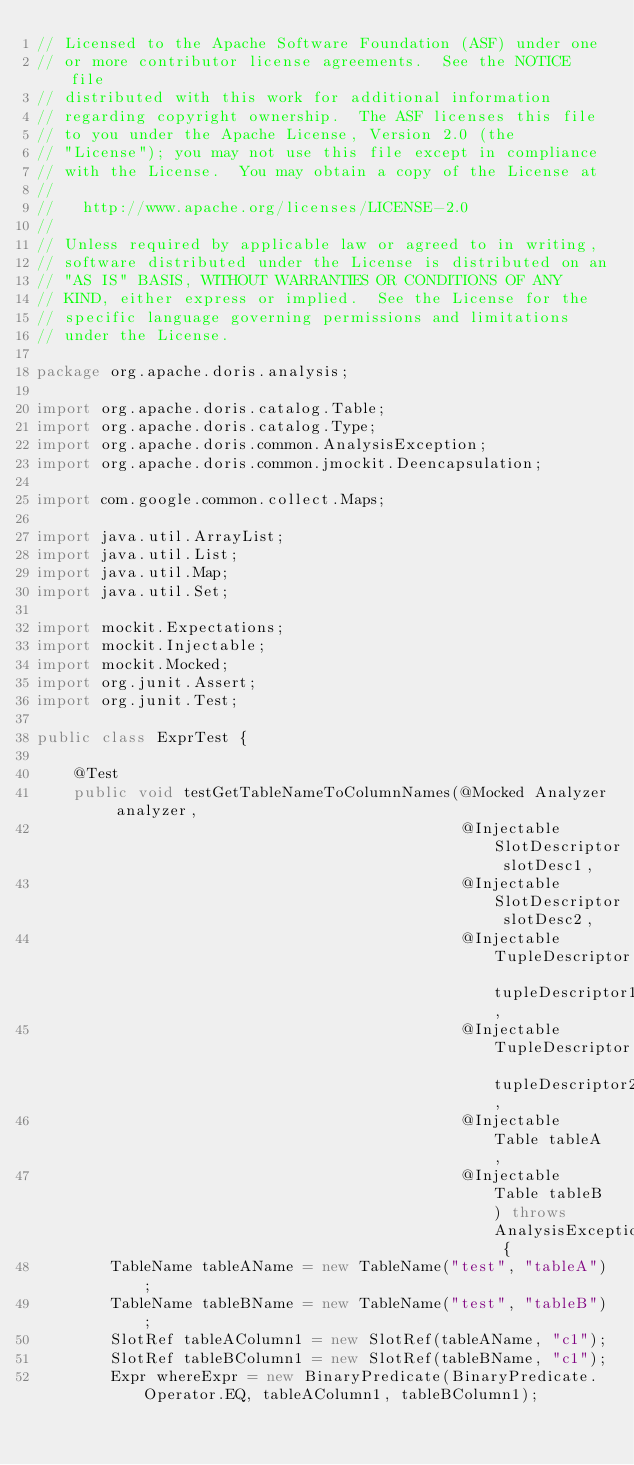Convert code to text. <code><loc_0><loc_0><loc_500><loc_500><_Java_>// Licensed to the Apache Software Foundation (ASF) under one
// or more contributor license agreements.  See the NOTICE file
// distributed with this work for additional information
// regarding copyright ownership.  The ASF licenses this file
// to you under the Apache License, Version 2.0 (the
// "License"); you may not use this file except in compliance
// with the License.  You may obtain a copy of the License at
//
//   http://www.apache.org/licenses/LICENSE-2.0
//
// Unless required by applicable law or agreed to in writing,
// software distributed under the License is distributed on an
// "AS IS" BASIS, WITHOUT WARRANTIES OR CONDITIONS OF ANY
// KIND, either express or implied.  See the License for the
// specific language governing permissions and limitations
// under the License.

package org.apache.doris.analysis;

import org.apache.doris.catalog.Table;
import org.apache.doris.catalog.Type;
import org.apache.doris.common.AnalysisException;
import org.apache.doris.common.jmockit.Deencapsulation;

import com.google.common.collect.Maps;

import java.util.ArrayList;
import java.util.List;
import java.util.Map;
import java.util.Set;

import mockit.Expectations;
import mockit.Injectable;
import mockit.Mocked;
import org.junit.Assert;
import org.junit.Test;

public class ExprTest {

    @Test
    public void testGetTableNameToColumnNames(@Mocked Analyzer analyzer,
                                              @Injectable SlotDescriptor slotDesc1,
                                              @Injectable SlotDescriptor slotDesc2,
                                              @Injectable TupleDescriptor tupleDescriptor1,
                                              @Injectable TupleDescriptor tupleDescriptor2,
                                              @Injectable Table tableA,
                                              @Injectable Table tableB) throws AnalysisException {
        TableName tableAName = new TableName("test", "tableA");
        TableName tableBName = new TableName("test", "tableB");
        SlotRef tableAColumn1 = new SlotRef(tableAName, "c1");
        SlotRef tableBColumn1 = new SlotRef(tableBName, "c1");
        Expr whereExpr = new BinaryPredicate(BinaryPredicate.Operator.EQ, tableAColumn1, tableBColumn1);</code> 